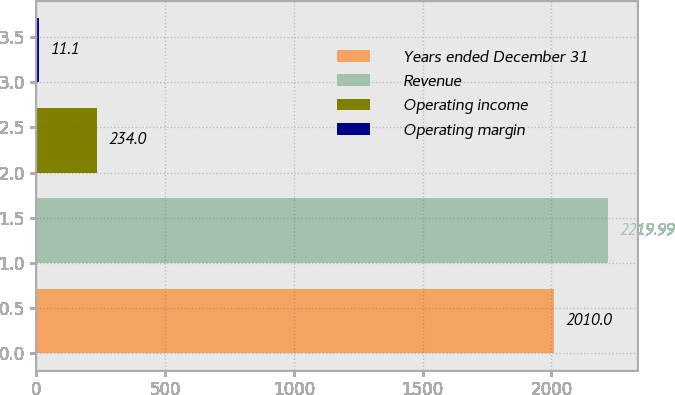Convert chart. <chart><loc_0><loc_0><loc_500><loc_500><bar_chart><fcel>Years ended December 31<fcel>Revenue<fcel>Operating income<fcel>Operating margin<nl><fcel>2010<fcel>2219.99<fcel>234<fcel>11.1<nl></chart> 